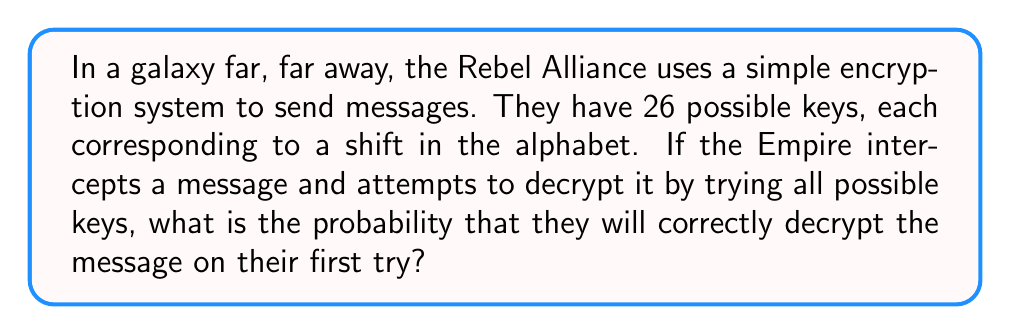Solve this math problem. Let's approach this step-by-step:

1) The Rebel Alliance is using a Caesar cipher, which has 26 possible keys (one for each letter of the alphabet).

2) Each key has an equal probability of being used.

3) The probability of an event is calculated by dividing the number of favorable outcomes by the total number of possible outcomes:

   $$ P(\text{event}) = \frac{\text{favorable outcomes}}{\text{total outcomes}} $$

4) In this case:
   - There is only 1 correct key (favorable outcome)
   - There are 26 total possible keys (total outcomes)

5) Therefore, the probability of choosing the correct key on the first try is:

   $$ P(\text{correct key}) = \frac{1}{26} \approx 0.0385 $$

6) We can express this as a percentage:

   $$ 0.0385 \times 100\% = 3.85\% $$
Answer: $\frac{1}{26}$ or approximately 3.85% 